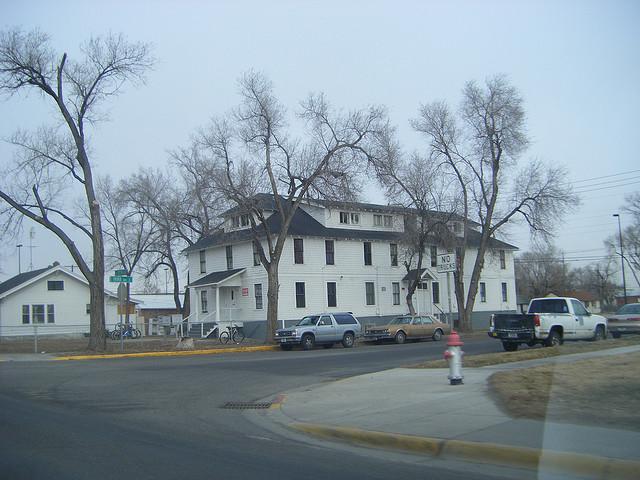Are there cones?
Write a very short answer. No. Are there any sidewalks visible in this photo?
Concise answer only. Yes. Is the vehicle moving?
Write a very short answer. No. IS this an urban or rural area?
Give a very brief answer. Rural. Why are the trees bare?
Be succinct. Winter. Is it a sunny day?
Keep it brief. No. What color are the lines painted on the pavement?
Keep it brief. Yellow. What color is the edge of the sidewalk?
Be succinct. Yellow. Is it safe to drive?
Short answer required. Yes. Is the home sitting close to the road?
Concise answer only. Yes. Are the cars headlights on?
Write a very short answer. No. How many bikes are there?
Give a very brief answer. 1. What is the building made out of?
Short answer required. Wood. What color is the hydrant?
Concise answer only. Silver and red. What color is the fire hydrant?
Keep it brief. Silver and red. Is the person crossing the street?
Write a very short answer. No. Are the cars parked in front of an apartment complex?
Give a very brief answer. Yes. 